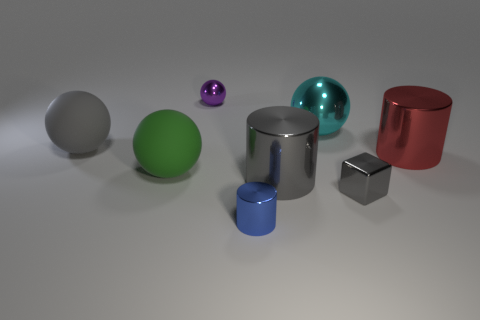The rubber object that is the same color as the shiny block is what shape?
Your answer should be very brief. Sphere. How many tiny objects are purple balls or matte things?
Make the answer very short. 1. What number of other large matte objects are the same shape as the green object?
Your response must be concise. 1. What material is the large cylinder left of the large cyan sphere that is behind the small gray shiny cube made of?
Your response must be concise. Metal. What is the size of the ball right of the blue shiny cylinder?
Your answer should be compact. Large. How many green things are cylinders or rubber things?
Keep it short and to the point. 1. Are there any other things that are made of the same material as the purple thing?
Keep it short and to the point. Yes. What material is the big cyan thing that is the same shape as the purple metallic thing?
Your answer should be compact. Metal. Are there an equal number of gray shiny cubes that are left of the cyan metal sphere and cylinders?
Offer a terse response. No. There is a cylinder that is behind the blue thing and to the left of the red metal cylinder; how big is it?
Give a very brief answer. Large. 